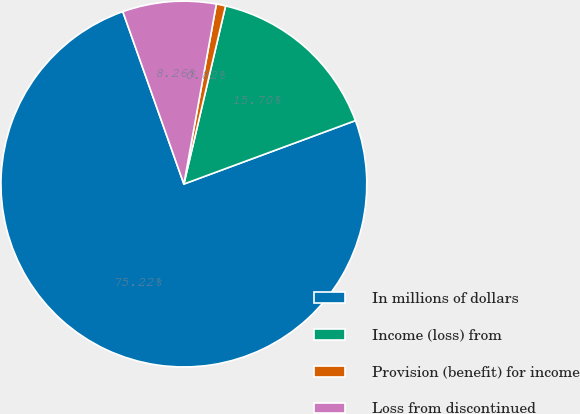<chart> <loc_0><loc_0><loc_500><loc_500><pie_chart><fcel>In millions of dollars<fcel>Income (loss) from<fcel>Provision (benefit) for income<fcel>Loss from discontinued<nl><fcel>75.22%<fcel>15.7%<fcel>0.82%<fcel>8.26%<nl></chart> 